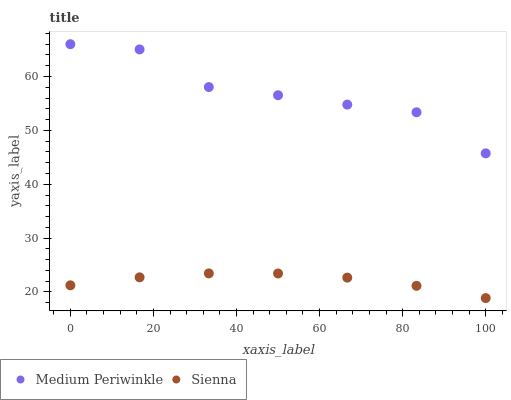Does Sienna have the minimum area under the curve?
Answer yes or no. Yes. Does Medium Periwinkle have the maximum area under the curve?
Answer yes or no. Yes. Does Medium Periwinkle have the minimum area under the curve?
Answer yes or no. No. Is Sienna the smoothest?
Answer yes or no. Yes. Is Medium Periwinkle the roughest?
Answer yes or no. Yes. Is Medium Periwinkle the smoothest?
Answer yes or no. No. Does Sienna have the lowest value?
Answer yes or no. Yes. Does Medium Periwinkle have the lowest value?
Answer yes or no. No. Does Medium Periwinkle have the highest value?
Answer yes or no. Yes. Is Sienna less than Medium Periwinkle?
Answer yes or no. Yes. Is Medium Periwinkle greater than Sienna?
Answer yes or no. Yes. Does Sienna intersect Medium Periwinkle?
Answer yes or no. No. 